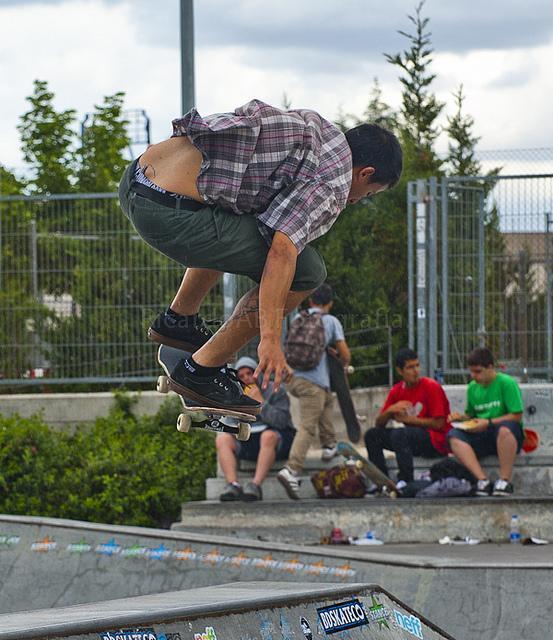How many people are visible?
Give a very brief answer. 5. 